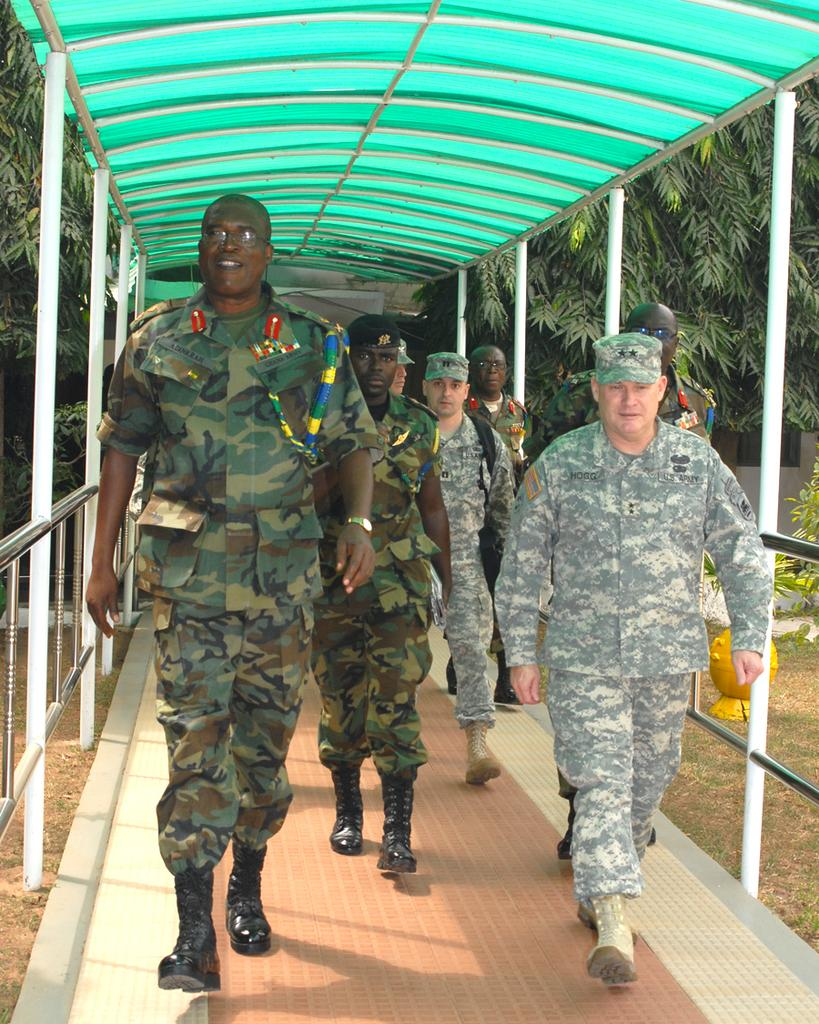What type of clothing are the men in the image wearing? The men are wearing camouflage dress in the image. What structure can be seen in the image? There is a shed in the image. What type of vegetation is visible in the image? There are trees visible in the image. What are the men doing in the image? The men are walking under the shed. What is the men's interest in the image? The provided facts do not mention any specific interests of the men in the image. What is the chance of the men playing with balls in the image? There is no information about balls or any related activity in the image. 